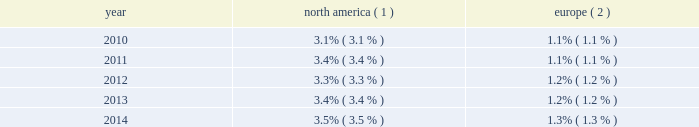Royal caribbean cruises ltd .
15 from two to 17 nights throughout south america , the caribbean and europe .
Additionally , we announced that majesty of the seas will be redeployed from royal caribbean international to pullmantur in 2016 .
Pullmantur serves the contemporary segment of the spanish , portuguese and latin american cruise mar- kets .
Pullmantur 2019s strategy is to attract cruise guests from these target markets by providing a variety of cruising options and onboard activities directed at couples and families traveling with children .
Over the last few years , pullmantur has systematically increased its focus on latin america and has expanded its pres- ence in that market .
In order to facilitate pullmantur 2019s ability to focus on its core cruise business , on march 31 , 2014 , pullmantur sold the majority of its interest in its non-core busi- nesses .
These non-core businesses included pullmantur 2019s land-based tour operations , travel agency and 49% ( 49 % ) interest in its air business .
In connection with the sale agreement , we retained a 19% ( 19 % ) interest in each of the non-core businesses as well as 100% ( 100 % ) ownership of the aircraft which are being dry leased to pullmantur air .
See note 1 .
General and note 6 .
Other assets to our consolidated financial statements under item 8 .
Financial statements and supplementary data for further details .
Cdf croisi e8res de france we currently operate two ships with an aggregate capacity of approximately 2800 berths under our cdf croisi e8res de france brand .
Cdf croisi e8res de france offers seasonal itineraries to the mediterranean , europe and caribbean .
During the winter season , zenith is deployed to the pullmantur brand for sailings in south america .
Cdf croisi e8res de france is designed to serve the contemporary segment of the french cruise market by providing a brand tailored for french cruise guests .
Tui cruises tui cruises is a joint venture owned 50% ( 50 % ) by us and 50% ( 50 % ) by tui ag , a german tourism and shipping com- pany , and is designed to serve the contemporary and premium segments of the german cruise market by offering a product tailored for german guests .
All onboard activities , services , shore excursions and menu offerings are designed to suit the preferences of this target market .
Tui cruises operates three ships , mein schiff 1 , mein schiff 2 and mein schiff 3 , with an aggregate capacity of approximately 6300 berths .
In addition , tui cruises currently has three newbuild ships on order at the finnish meyer turku yard with an aggregate capacity of approximately 7500 berths : mein schiff 4 , scheduled for delivery in the second quarter of 2015 , mein schiff 5 , scheduled for delivery in the third quarter of 2016 and mein schiff 6 , scheduled for delivery in the second quarter of 2017 .
In november 2014 , we formed a strategic partnership with ctrip.com international ltd .
( 201cctrip 201d ) , a chinese travel service provider , to operate a new cruise brand known as skysea cruises .
Skysea cruises will offer a custom-tailored product for chinese cruise guests operating the ship purchased from celebrity cruises .
The new cruise line will begin service in the second quarter of 2015 .
We and ctrip each own 35% ( 35 % ) of the new company , skysea holding , with the balance being owned by skysea holding management and a private equity fund .
Industry cruising is considered a well-established vacation sector in the north american market , a growing sec- tor over the long term in the european market and a developing but promising sector in several other emerging markets .
Industry data indicates that market penetration rates are still low and that a significant portion of cruise guests carried are first-time cruisers .
We believe this presents an opportunity for long-term growth and a potential for increased profitability .
The table details market penetration rates for north america and europe computed based on the number of annual cruise guests as a percentage of the total population : america ( 1 ) europe ( 2 ) .
( 1 ) source : our estimates are based on a combination of data obtained from publicly available sources including the interna- tional monetary fund and cruise lines international association ( 201cclia 201d ) .
Rates are based on cruise guests carried for at least two consecutive nights .
Includes the united states of america and canada .
( 2 ) source : our estimates are based on a combination of data obtained from publicly available sources including the interna- tional monetary fund and clia europe , formerly european cruise council .
We estimate that the global cruise fleet was served by approximately 457000 berths on approximately 283 ships at the end of 2014 .
There are approximately 33 ships with an estimated 98650 berths that are expected to be placed in service in the global cruise market between 2015 and 2019 , although it is also possible that ships could be ordered or taken out of service during these periods .
We estimate that the global cruise industry carried 22.0 million cruise guests in 2014 compared to 21.3 million cruise guests carried in 2013 and 20.9 million cruise guests carried in 2012 .
Part i .
What is the estimated percentage increase , from 2012 to 2014 , in total global cruise guests? 
Computations: (((22.0 - 20.9) / 20.9) * 100)
Answer: 5.26316. 